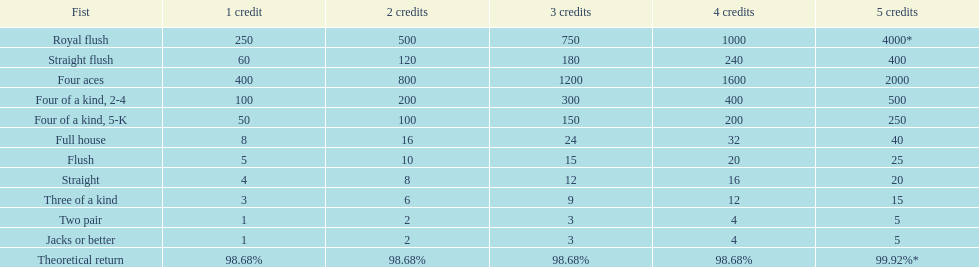What is the payout for achieving a full house and winning on four credits? 32. 